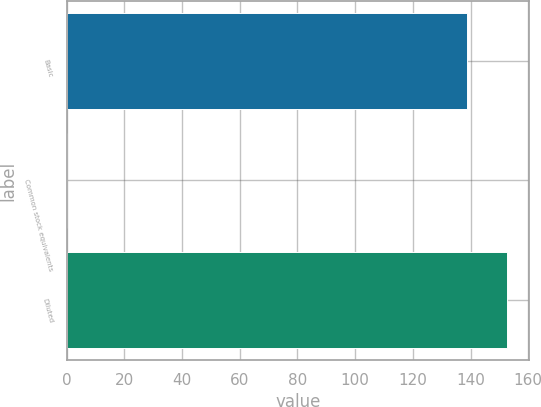<chart> <loc_0><loc_0><loc_500><loc_500><bar_chart><fcel>Basic<fcel>Common stock equivalents<fcel>Diluted<nl><fcel>138.8<fcel>0.2<fcel>152.68<nl></chart> 